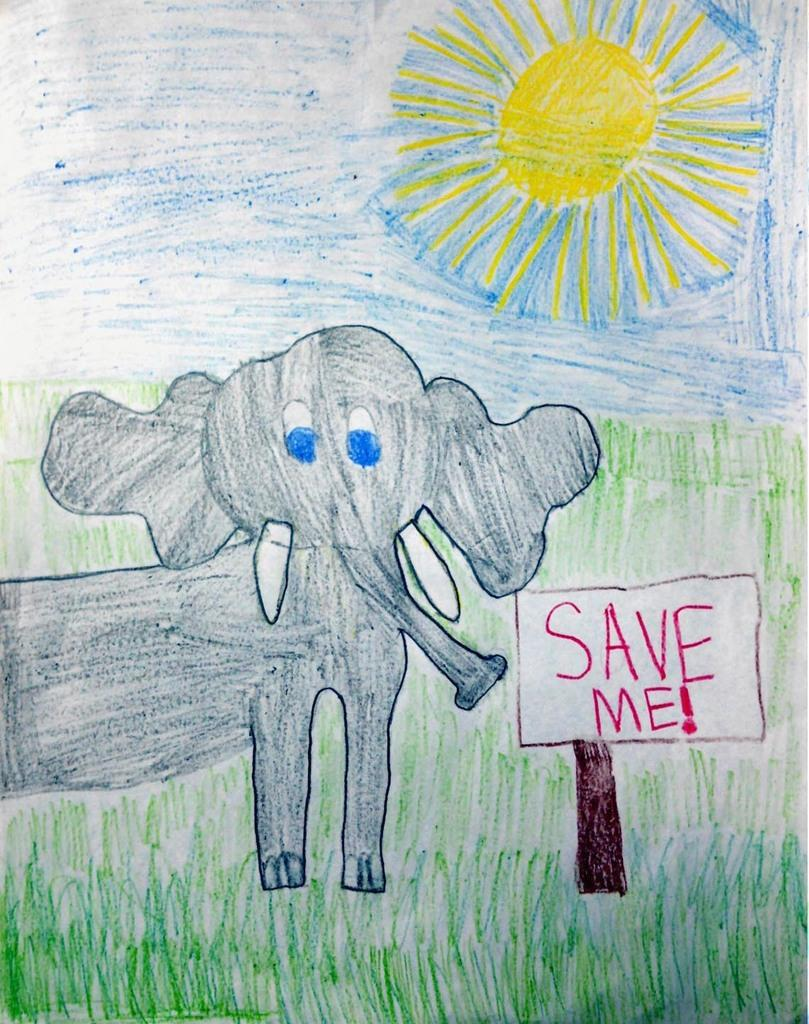What is depicted in the image? There is a painting in the image. What elements can be found in the painting? The painting contains grass, an elephant, the Sun, and a board. Can you describe the setting of the painting? The painting features an elephant in a grassy area with the Sun above and a board nearby. What type of wine is being served at the feast in the painting? There is no feast or wine present in the painting; it features an elephant in a grassy area with the Sun above and a board nearby. 